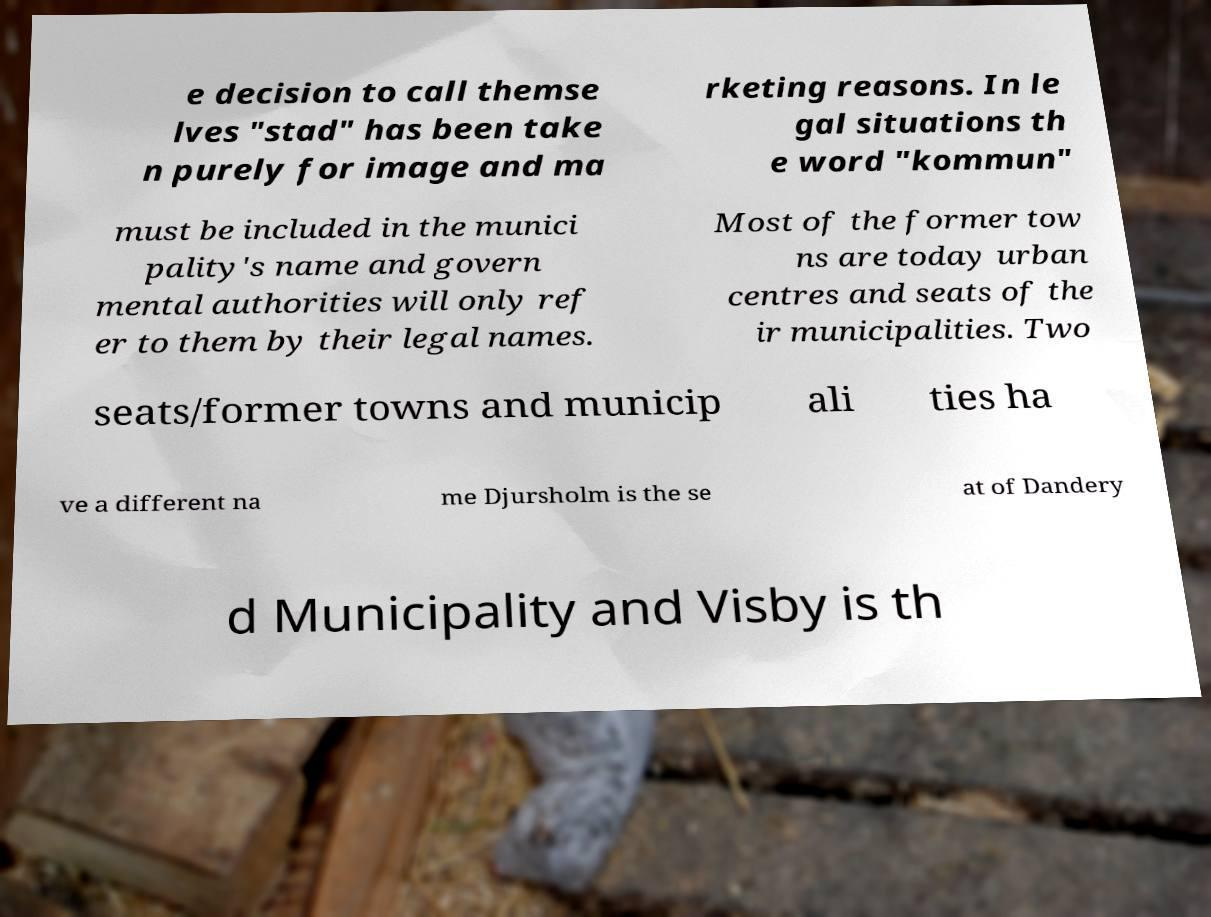I need the written content from this picture converted into text. Can you do that? e decision to call themse lves "stad" has been take n purely for image and ma rketing reasons. In le gal situations th e word "kommun" must be included in the munici pality's name and govern mental authorities will only ref er to them by their legal names. Most of the former tow ns are today urban centres and seats of the ir municipalities. Two seats/former towns and municip ali ties ha ve a different na me Djursholm is the se at of Dandery d Municipality and Visby is th 